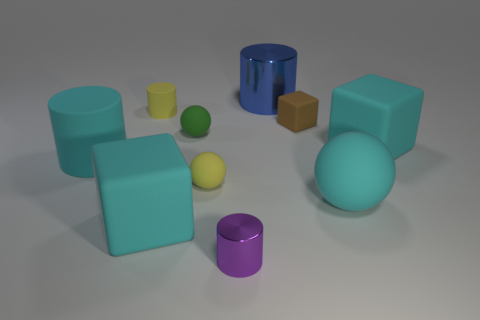How many objects are either large green rubber balls or yellow objects in front of the small brown thing?
Ensure brevity in your answer.  1. The small rubber cylinder is what color?
Your response must be concise. Yellow. What is the material of the big cylinder behind the rubber sphere behind the yellow thing that is right of the yellow matte cylinder?
Provide a succinct answer. Metal. There is a yellow ball that is the same material as the tiny green object; what size is it?
Make the answer very short. Small. Is there a rubber block that has the same color as the big matte cylinder?
Provide a succinct answer. Yes. There is a cyan matte sphere; does it have the same size as the cyan cube that is on the right side of the big metal cylinder?
Offer a very short reply. Yes. What number of small yellow cylinders are left of the small object right of the metal object that is behind the brown block?
Your answer should be compact. 1. There is a ball that is the same color as the small rubber cylinder; what size is it?
Keep it short and to the point. Small. There is a small yellow matte ball; are there any large cyan rubber cubes in front of it?
Give a very brief answer. Yes. The tiny green object has what shape?
Keep it short and to the point. Sphere. 